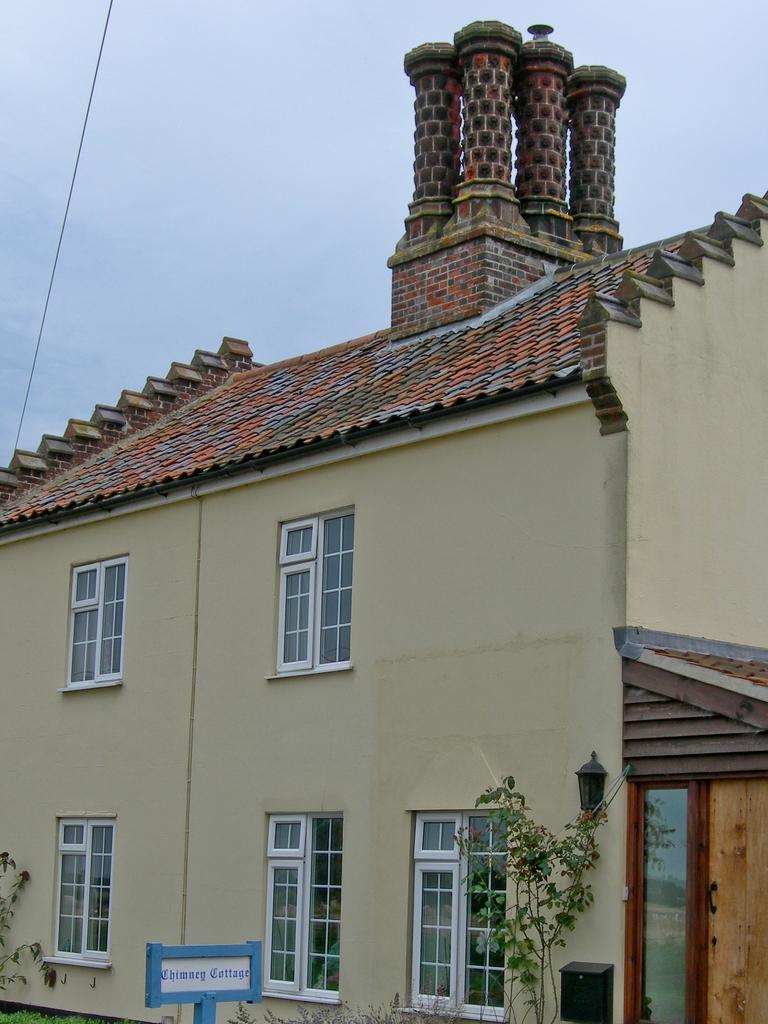Please provide a concise description of this image. The picture consists of a building. At the bottom there are plants, name board, post box and windows. At the top we can see sky and cable. 